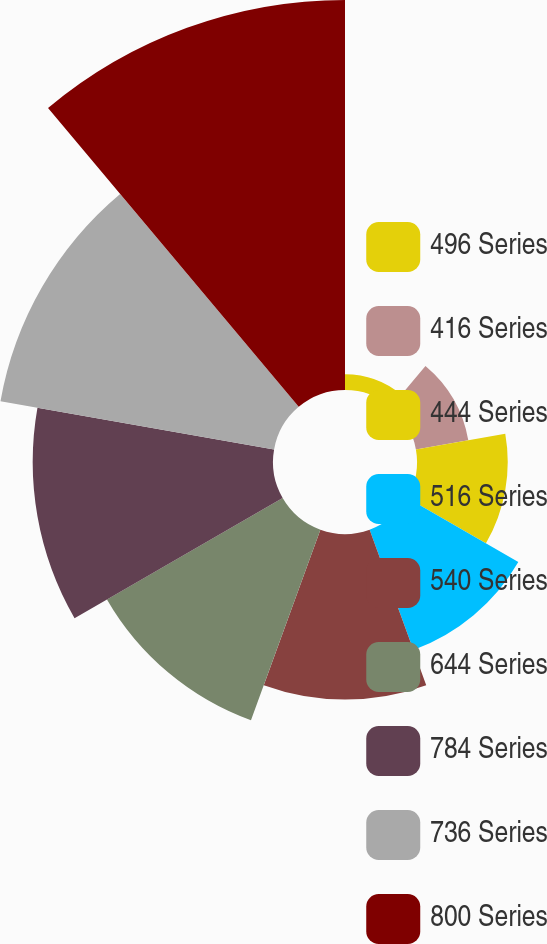Convert chart. <chart><loc_0><loc_0><loc_500><loc_500><pie_chart><fcel>496 Series<fcel>416 Series<fcel>444 Series<fcel>516 Series<fcel>540 Series<fcel>644 Series<fcel>784 Series<fcel>736 Series<fcel>800 Series<nl><fcel>1.01%<fcel>3.4%<fcel>5.8%<fcel>8.19%<fcel>10.58%<fcel>12.97%<fcel>15.36%<fcel>17.76%<fcel>24.93%<nl></chart> 